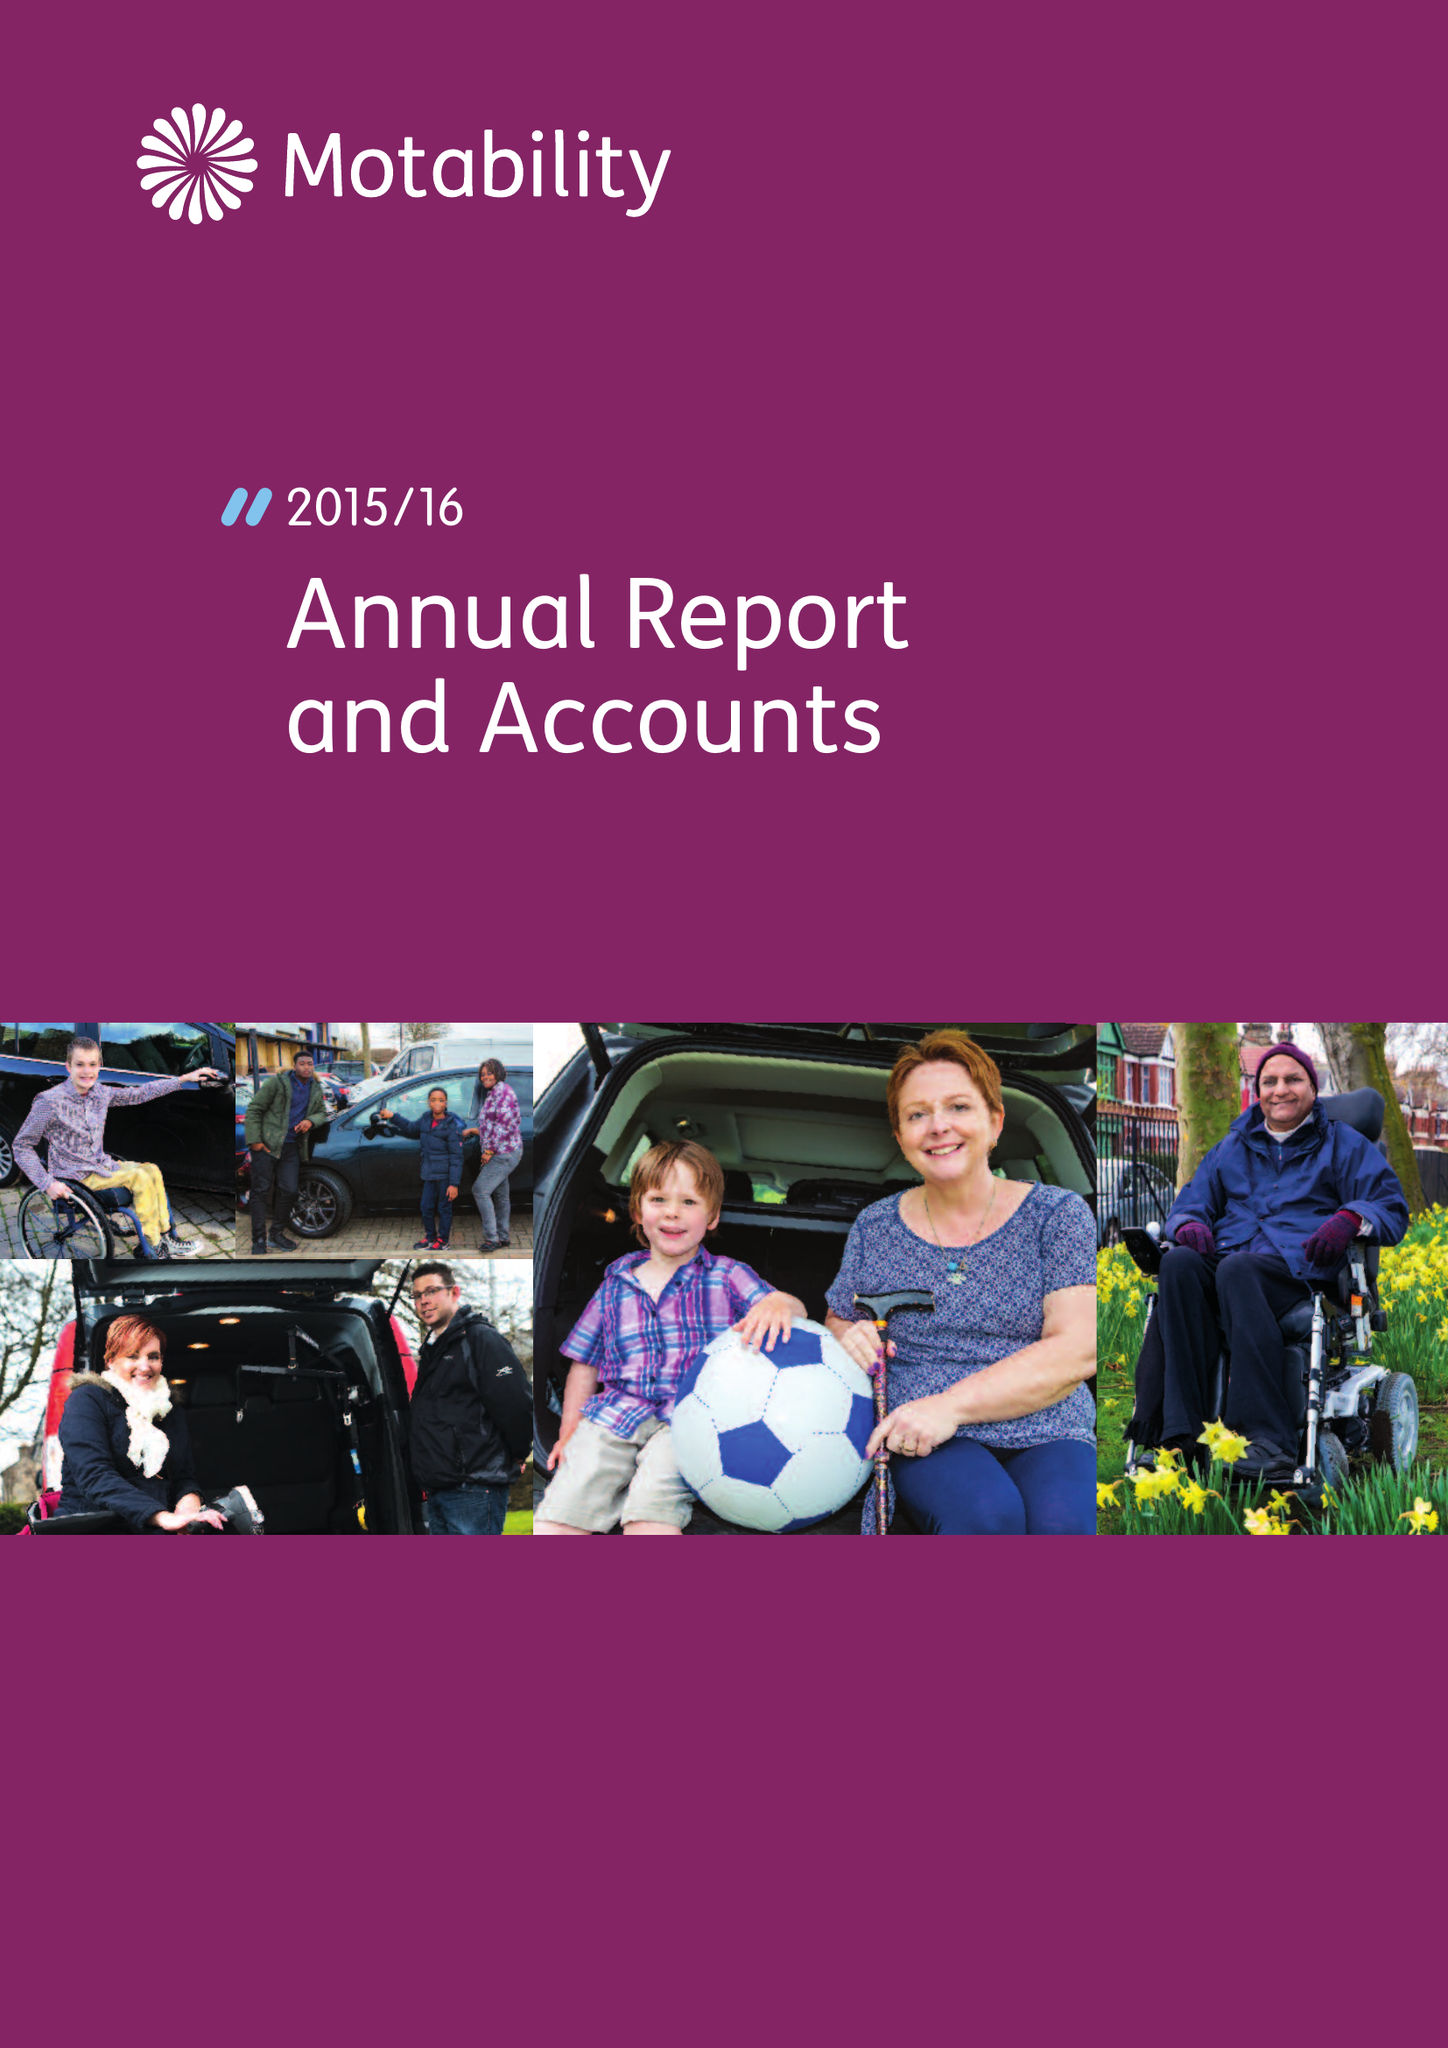What is the value for the charity_number?
Answer the question using a single word or phrase. 299745 